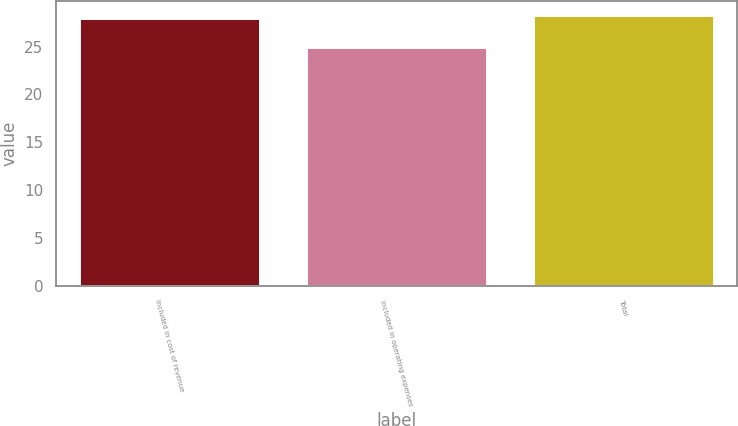<chart> <loc_0><loc_0><loc_500><loc_500><bar_chart><fcel>Included in cost of revenue<fcel>Included in operating expenses<fcel>Total<nl><fcel>28<fcel>25<fcel>28.3<nl></chart> 